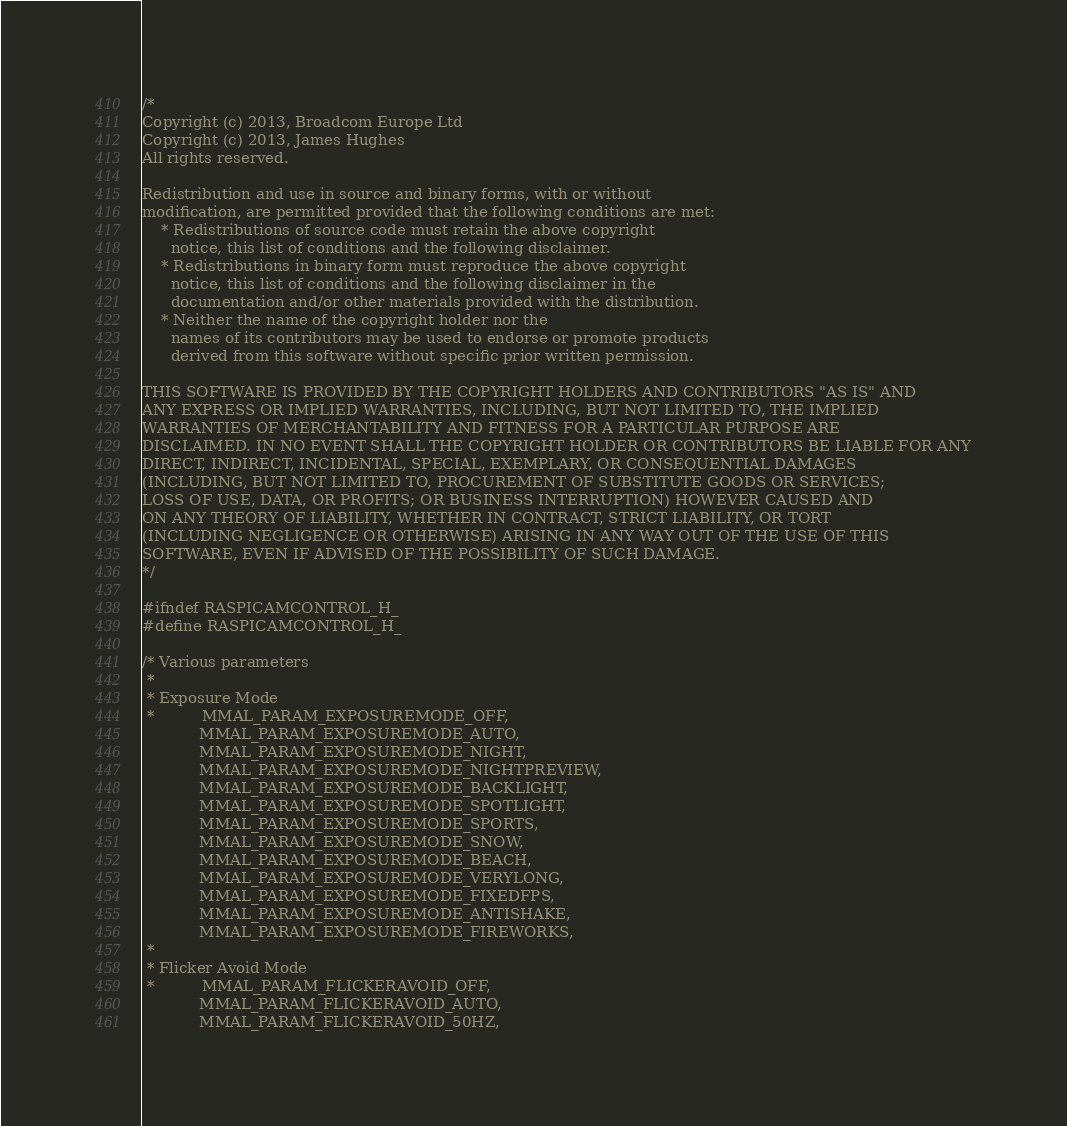<code> <loc_0><loc_0><loc_500><loc_500><_C_>/*
Copyright (c) 2013, Broadcom Europe Ltd
Copyright (c) 2013, James Hughes
All rights reserved.

Redistribution and use in source and binary forms, with or without
modification, are permitted provided that the following conditions are met:
    * Redistributions of source code must retain the above copyright
      notice, this list of conditions and the following disclaimer.
    * Redistributions in binary form must reproduce the above copyright
      notice, this list of conditions and the following disclaimer in the
      documentation and/or other materials provided with the distribution.
    * Neither the name of the copyright holder nor the
      names of its contributors may be used to endorse or promote products
      derived from this software without specific prior written permission.

THIS SOFTWARE IS PROVIDED BY THE COPYRIGHT HOLDERS AND CONTRIBUTORS "AS IS" AND
ANY EXPRESS OR IMPLIED WARRANTIES, INCLUDING, BUT NOT LIMITED TO, THE IMPLIED
WARRANTIES OF MERCHANTABILITY AND FITNESS FOR A PARTICULAR PURPOSE ARE
DISCLAIMED. IN NO EVENT SHALL THE COPYRIGHT HOLDER OR CONTRIBUTORS BE LIABLE FOR ANY
DIRECT, INDIRECT, INCIDENTAL, SPECIAL, EXEMPLARY, OR CONSEQUENTIAL DAMAGES
(INCLUDING, BUT NOT LIMITED TO, PROCUREMENT OF SUBSTITUTE GOODS OR SERVICES;
LOSS OF USE, DATA, OR PROFITS; OR BUSINESS INTERRUPTION) HOWEVER CAUSED AND
ON ANY THEORY OF LIABILITY, WHETHER IN CONTRACT, STRICT LIABILITY, OR TORT
(INCLUDING NEGLIGENCE OR OTHERWISE) ARISING IN ANY WAY OUT OF THE USE OF THIS
SOFTWARE, EVEN IF ADVISED OF THE POSSIBILITY OF SUCH DAMAGE.
*/

#ifndef RASPICAMCONTROL_H_
#define RASPICAMCONTROL_H_

/* Various parameters
 *
 * Exposure Mode
 *          MMAL_PARAM_EXPOSUREMODE_OFF,
            MMAL_PARAM_EXPOSUREMODE_AUTO,
            MMAL_PARAM_EXPOSUREMODE_NIGHT,
            MMAL_PARAM_EXPOSUREMODE_NIGHTPREVIEW,
            MMAL_PARAM_EXPOSUREMODE_BACKLIGHT,
            MMAL_PARAM_EXPOSUREMODE_SPOTLIGHT,
            MMAL_PARAM_EXPOSUREMODE_SPORTS,
            MMAL_PARAM_EXPOSUREMODE_SNOW,
            MMAL_PARAM_EXPOSUREMODE_BEACH,
            MMAL_PARAM_EXPOSUREMODE_VERYLONG,
            MMAL_PARAM_EXPOSUREMODE_FIXEDFPS,
            MMAL_PARAM_EXPOSUREMODE_ANTISHAKE,
            MMAL_PARAM_EXPOSUREMODE_FIREWORKS,
 *
 * Flicker Avoid Mode
 *          MMAL_PARAM_FLICKERAVOID_OFF,
            MMAL_PARAM_FLICKERAVOID_AUTO,
            MMAL_PARAM_FLICKERAVOID_50HZ,</code> 